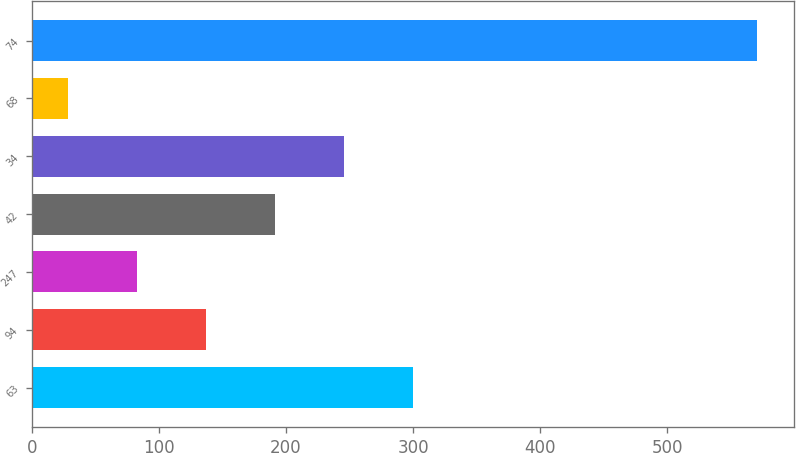<chart> <loc_0><loc_0><loc_500><loc_500><bar_chart><fcel>63<fcel>94<fcel>247<fcel>42<fcel>34<fcel>68<fcel>74<nl><fcel>299.75<fcel>137.06<fcel>82.83<fcel>191.29<fcel>245.52<fcel>28.6<fcel>570.9<nl></chart> 